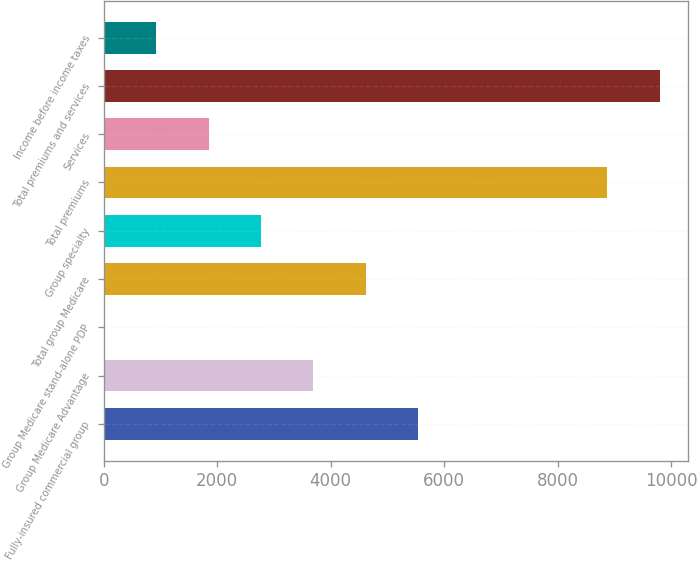Convert chart to OTSL. <chart><loc_0><loc_0><loc_500><loc_500><bar_chart><fcel>Fully-insured commercial group<fcel>Group Medicare Advantage<fcel>Group Medicare stand-alone PDP<fcel>Total group Medicare<fcel>Group specialty<fcel>Total premiums<fcel>Services<fcel>Total premiums and services<fcel>Income before income taxes<nl><fcel>5543<fcel>3698<fcel>8<fcel>4620.5<fcel>2775.5<fcel>8877<fcel>1853<fcel>9799.5<fcel>930.5<nl></chart> 